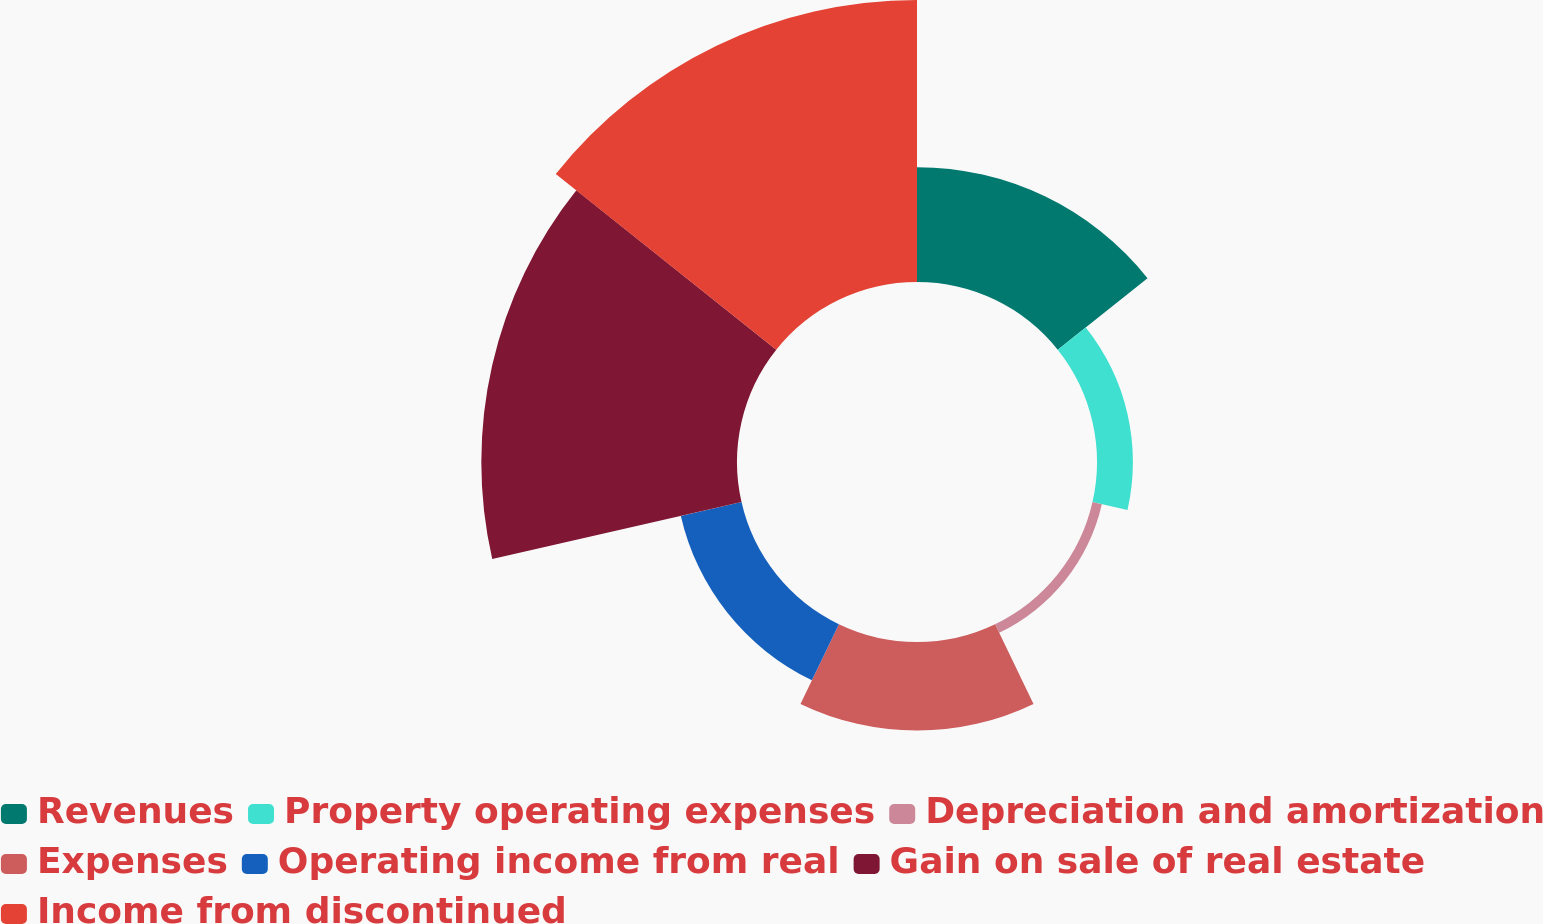<chart> <loc_0><loc_0><loc_500><loc_500><pie_chart><fcel>Revenues<fcel>Property operating expenses<fcel>Depreciation and amortization<fcel>Expenses<fcel>Operating income from real<fcel>Gain on sale of real estate<fcel>Income from discontinued<nl><fcel>13.53%<fcel>4.23%<fcel>1.13%<fcel>10.43%<fcel>7.33%<fcel>30.12%<fcel>33.22%<nl></chart> 